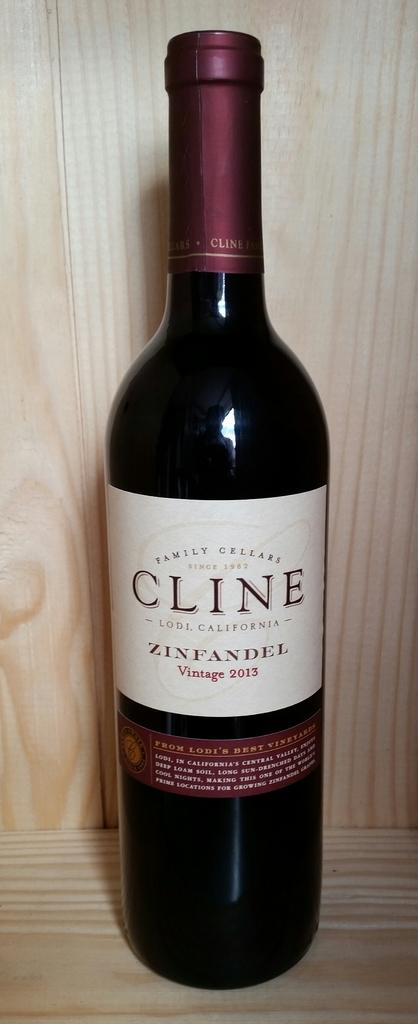<image>
Relay a brief, clear account of the picture shown. A zinfandel wine bottle from 2013 sitting on a wood surface. 